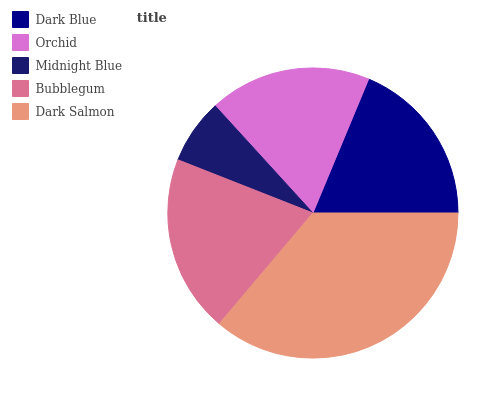Is Midnight Blue the minimum?
Answer yes or no. Yes. Is Dark Salmon the maximum?
Answer yes or no. Yes. Is Orchid the minimum?
Answer yes or no. No. Is Orchid the maximum?
Answer yes or no. No. Is Dark Blue greater than Orchid?
Answer yes or no. Yes. Is Orchid less than Dark Blue?
Answer yes or no. Yes. Is Orchid greater than Dark Blue?
Answer yes or no. No. Is Dark Blue less than Orchid?
Answer yes or no. No. Is Dark Blue the high median?
Answer yes or no. Yes. Is Dark Blue the low median?
Answer yes or no. Yes. Is Orchid the high median?
Answer yes or no. No. Is Dark Salmon the low median?
Answer yes or no. No. 